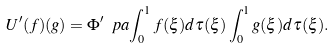Convert formula to latex. <formula><loc_0><loc_0><loc_500><loc_500>U ^ { \prime } ( f ) ( g ) = \Phi ^ { \prime } \ p a { \int _ { 0 } ^ { 1 } f ( \xi ) d \tau ( \xi ) } \int _ { 0 } ^ { 1 } g ( \xi ) d \tau ( \xi ) .</formula> 